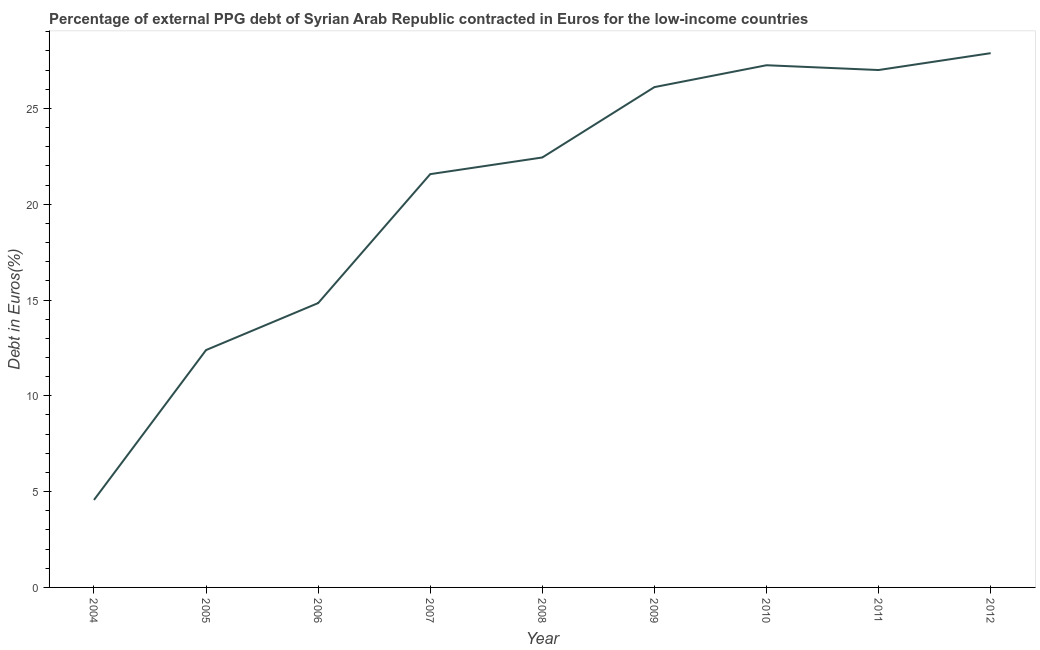What is the currency composition of ppg debt in 2004?
Ensure brevity in your answer.  4.57. Across all years, what is the maximum currency composition of ppg debt?
Provide a short and direct response. 27.88. Across all years, what is the minimum currency composition of ppg debt?
Your answer should be very brief. 4.57. In which year was the currency composition of ppg debt minimum?
Your response must be concise. 2004. What is the sum of the currency composition of ppg debt?
Your answer should be compact. 184.05. What is the difference between the currency composition of ppg debt in 2004 and 2010?
Offer a terse response. -22.69. What is the average currency composition of ppg debt per year?
Make the answer very short. 20.45. What is the median currency composition of ppg debt?
Provide a short and direct response. 22.44. In how many years, is the currency composition of ppg debt greater than 25 %?
Give a very brief answer. 4. Do a majority of the years between 2011 and 2007 (inclusive) have currency composition of ppg debt greater than 7 %?
Your answer should be very brief. Yes. What is the ratio of the currency composition of ppg debt in 2007 to that in 2009?
Provide a succinct answer. 0.83. Is the currency composition of ppg debt in 2005 less than that in 2011?
Offer a terse response. Yes. Is the difference between the currency composition of ppg debt in 2008 and 2011 greater than the difference between any two years?
Give a very brief answer. No. What is the difference between the highest and the second highest currency composition of ppg debt?
Your answer should be very brief. 0.63. Is the sum of the currency composition of ppg debt in 2007 and 2011 greater than the maximum currency composition of ppg debt across all years?
Your answer should be compact. Yes. What is the difference between the highest and the lowest currency composition of ppg debt?
Ensure brevity in your answer.  23.32. How many lines are there?
Keep it short and to the point. 1. How many years are there in the graph?
Your response must be concise. 9. Does the graph contain any zero values?
Keep it short and to the point. No. What is the title of the graph?
Ensure brevity in your answer.  Percentage of external PPG debt of Syrian Arab Republic contracted in Euros for the low-income countries. What is the label or title of the Y-axis?
Provide a succinct answer. Debt in Euros(%). What is the Debt in Euros(%) in 2004?
Your answer should be very brief. 4.57. What is the Debt in Euros(%) of 2005?
Ensure brevity in your answer.  12.39. What is the Debt in Euros(%) in 2006?
Provide a short and direct response. 14.84. What is the Debt in Euros(%) of 2007?
Give a very brief answer. 21.57. What is the Debt in Euros(%) of 2008?
Your answer should be very brief. 22.44. What is the Debt in Euros(%) in 2009?
Offer a very short reply. 26.11. What is the Debt in Euros(%) of 2010?
Provide a succinct answer. 27.25. What is the Debt in Euros(%) in 2011?
Your answer should be very brief. 27. What is the Debt in Euros(%) in 2012?
Offer a terse response. 27.88. What is the difference between the Debt in Euros(%) in 2004 and 2005?
Your response must be concise. -7.82. What is the difference between the Debt in Euros(%) in 2004 and 2006?
Provide a short and direct response. -10.27. What is the difference between the Debt in Euros(%) in 2004 and 2007?
Offer a very short reply. -17. What is the difference between the Debt in Euros(%) in 2004 and 2008?
Your answer should be compact. -17.87. What is the difference between the Debt in Euros(%) in 2004 and 2009?
Give a very brief answer. -21.55. What is the difference between the Debt in Euros(%) in 2004 and 2010?
Your answer should be very brief. -22.69. What is the difference between the Debt in Euros(%) in 2004 and 2011?
Offer a terse response. -22.44. What is the difference between the Debt in Euros(%) in 2004 and 2012?
Your response must be concise. -23.32. What is the difference between the Debt in Euros(%) in 2005 and 2006?
Offer a terse response. -2.45. What is the difference between the Debt in Euros(%) in 2005 and 2007?
Keep it short and to the point. -9.18. What is the difference between the Debt in Euros(%) in 2005 and 2008?
Your answer should be very brief. -10.05. What is the difference between the Debt in Euros(%) in 2005 and 2009?
Give a very brief answer. -13.72. What is the difference between the Debt in Euros(%) in 2005 and 2010?
Offer a very short reply. -14.86. What is the difference between the Debt in Euros(%) in 2005 and 2011?
Ensure brevity in your answer.  -14.61. What is the difference between the Debt in Euros(%) in 2005 and 2012?
Offer a terse response. -15.49. What is the difference between the Debt in Euros(%) in 2006 and 2007?
Offer a very short reply. -6.73. What is the difference between the Debt in Euros(%) in 2006 and 2008?
Provide a short and direct response. -7.6. What is the difference between the Debt in Euros(%) in 2006 and 2009?
Provide a short and direct response. -11.27. What is the difference between the Debt in Euros(%) in 2006 and 2010?
Your answer should be very brief. -12.41. What is the difference between the Debt in Euros(%) in 2006 and 2011?
Make the answer very short. -12.16. What is the difference between the Debt in Euros(%) in 2006 and 2012?
Offer a terse response. -13.04. What is the difference between the Debt in Euros(%) in 2007 and 2008?
Make the answer very short. -0.87. What is the difference between the Debt in Euros(%) in 2007 and 2009?
Keep it short and to the point. -4.54. What is the difference between the Debt in Euros(%) in 2007 and 2010?
Ensure brevity in your answer.  -5.68. What is the difference between the Debt in Euros(%) in 2007 and 2011?
Ensure brevity in your answer.  -5.43. What is the difference between the Debt in Euros(%) in 2007 and 2012?
Ensure brevity in your answer.  -6.31. What is the difference between the Debt in Euros(%) in 2008 and 2009?
Offer a terse response. -3.67. What is the difference between the Debt in Euros(%) in 2008 and 2010?
Provide a succinct answer. -4.81. What is the difference between the Debt in Euros(%) in 2008 and 2011?
Offer a terse response. -4.56. What is the difference between the Debt in Euros(%) in 2008 and 2012?
Keep it short and to the point. -5.44. What is the difference between the Debt in Euros(%) in 2009 and 2010?
Your response must be concise. -1.14. What is the difference between the Debt in Euros(%) in 2009 and 2011?
Keep it short and to the point. -0.89. What is the difference between the Debt in Euros(%) in 2009 and 2012?
Provide a succinct answer. -1.77. What is the difference between the Debt in Euros(%) in 2010 and 2011?
Ensure brevity in your answer.  0.25. What is the difference between the Debt in Euros(%) in 2010 and 2012?
Offer a very short reply. -0.63. What is the difference between the Debt in Euros(%) in 2011 and 2012?
Your answer should be compact. -0.88. What is the ratio of the Debt in Euros(%) in 2004 to that in 2005?
Offer a very short reply. 0.37. What is the ratio of the Debt in Euros(%) in 2004 to that in 2006?
Ensure brevity in your answer.  0.31. What is the ratio of the Debt in Euros(%) in 2004 to that in 2007?
Offer a very short reply. 0.21. What is the ratio of the Debt in Euros(%) in 2004 to that in 2008?
Offer a terse response. 0.2. What is the ratio of the Debt in Euros(%) in 2004 to that in 2009?
Provide a succinct answer. 0.17. What is the ratio of the Debt in Euros(%) in 2004 to that in 2010?
Offer a very short reply. 0.17. What is the ratio of the Debt in Euros(%) in 2004 to that in 2011?
Ensure brevity in your answer.  0.17. What is the ratio of the Debt in Euros(%) in 2004 to that in 2012?
Provide a short and direct response. 0.16. What is the ratio of the Debt in Euros(%) in 2005 to that in 2006?
Keep it short and to the point. 0.83. What is the ratio of the Debt in Euros(%) in 2005 to that in 2007?
Your answer should be very brief. 0.57. What is the ratio of the Debt in Euros(%) in 2005 to that in 2008?
Make the answer very short. 0.55. What is the ratio of the Debt in Euros(%) in 2005 to that in 2009?
Provide a short and direct response. 0.47. What is the ratio of the Debt in Euros(%) in 2005 to that in 2010?
Your response must be concise. 0.46. What is the ratio of the Debt in Euros(%) in 2005 to that in 2011?
Offer a very short reply. 0.46. What is the ratio of the Debt in Euros(%) in 2005 to that in 2012?
Make the answer very short. 0.44. What is the ratio of the Debt in Euros(%) in 2006 to that in 2007?
Offer a terse response. 0.69. What is the ratio of the Debt in Euros(%) in 2006 to that in 2008?
Make the answer very short. 0.66. What is the ratio of the Debt in Euros(%) in 2006 to that in 2009?
Your response must be concise. 0.57. What is the ratio of the Debt in Euros(%) in 2006 to that in 2010?
Your response must be concise. 0.55. What is the ratio of the Debt in Euros(%) in 2006 to that in 2011?
Your answer should be very brief. 0.55. What is the ratio of the Debt in Euros(%) in 2006 to that in 2012?
Make the answer very short. 0.53. What is the ratio of the Debt in Euros(%) in 2007 to that in 2008?
Your answer should be compact. 0.96. What is the ratio of the Debt in Euros(%) in 2007 to that in 2009?
Keep it short and to the point. 0.83. What is the ratio of the Debt in Euros(%) in 2007 to that in 2010?
Provide a short and direct response. 0.79. What is the ratio of the Debt in Euros(%) in 2007 to that in 2011?
Give a very brief answer. 0.8. What is the ratio of the Debt in Euros(%) in 2007 to that in 2012?
Your response must be concise. 0.77. What is the ratio of the Debt in Euros(%) in 2008 to that in 2009?
Ensure brevity in your answer.  0.86. What is the ratio of the Debt in Euros(%) in 2008 to that in 2010?
Provide a succinct answer. 0.82. What is the ratio of the Debt in Euros(%) in 2008 to that in 2011?
Provide a short and direct response. 0.83. What is the ratio of the Debt in Euros(%) in 2008 to that in 2012?
Your response must be concise. 0.81. What is the ratio of the Debt in Euros(%) in 2009 to that in 2010?
Your answer should be very brief. 0.96. What is the ratio of the Debt in Euros(%) in 2009 to that in 2011?
Provide a succinct answer. 0.97. What is the ratio of the Debt in Euros(%) in 2009 to that in 2012?
Your answer should be compact. 0.94. What is the ratio of the Debt in Euros(%) in 2010 to that in 2011?
Keep it short and to the point. 1.01. What is the ratio of the Debt in Euros(%) in 2010 to that in 2012?
Offer a very short reply. 0.98. 